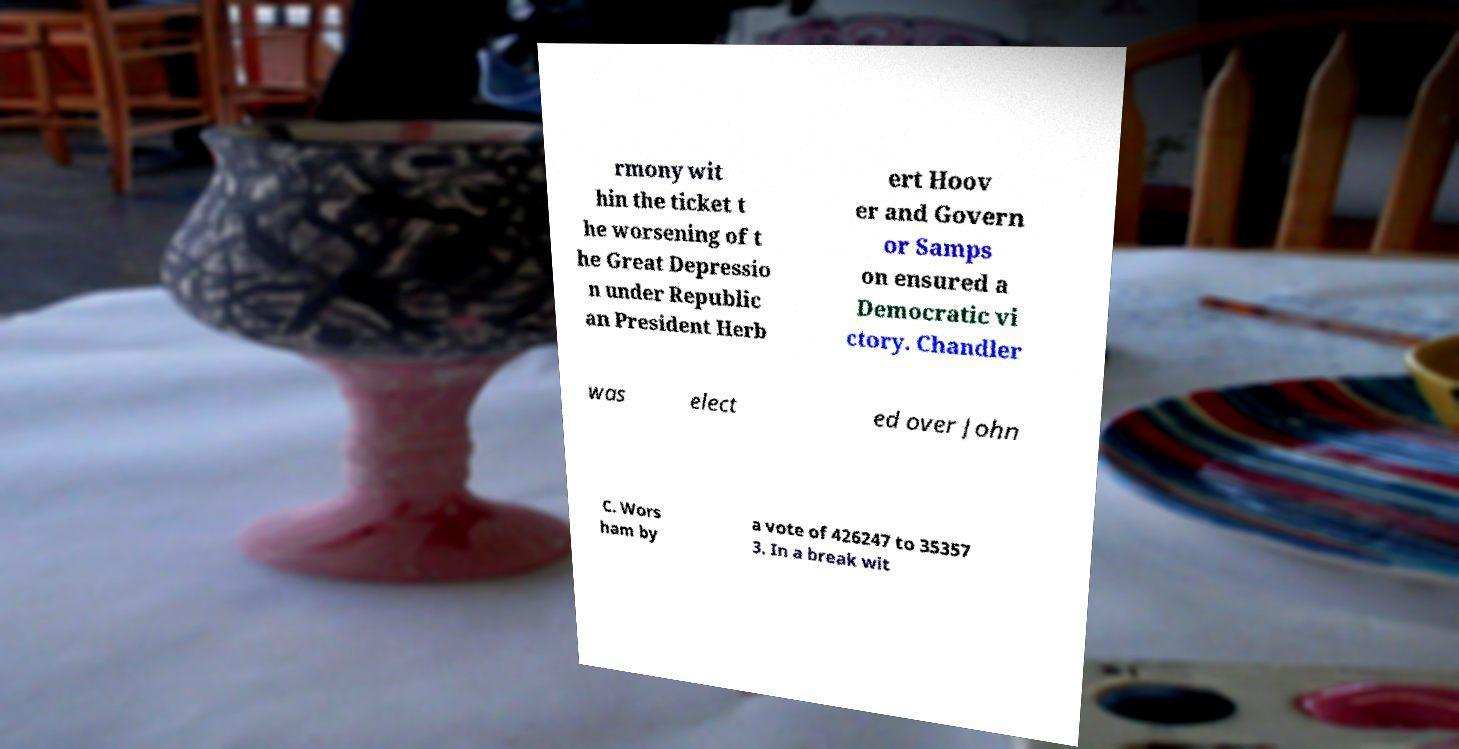There's text embedded in this image that I need extracted. Can you transcribe it verbatim? rmony wit hin the ticket t he worsening of t he Great Depressio n under Republic an President Herb ert Hoov er and Govern or Samps on ensured a Democratic vi ctory. Chandler was elect ed over John C. Wors ham by a vote of 426247 to 35357 3. In a break wit 